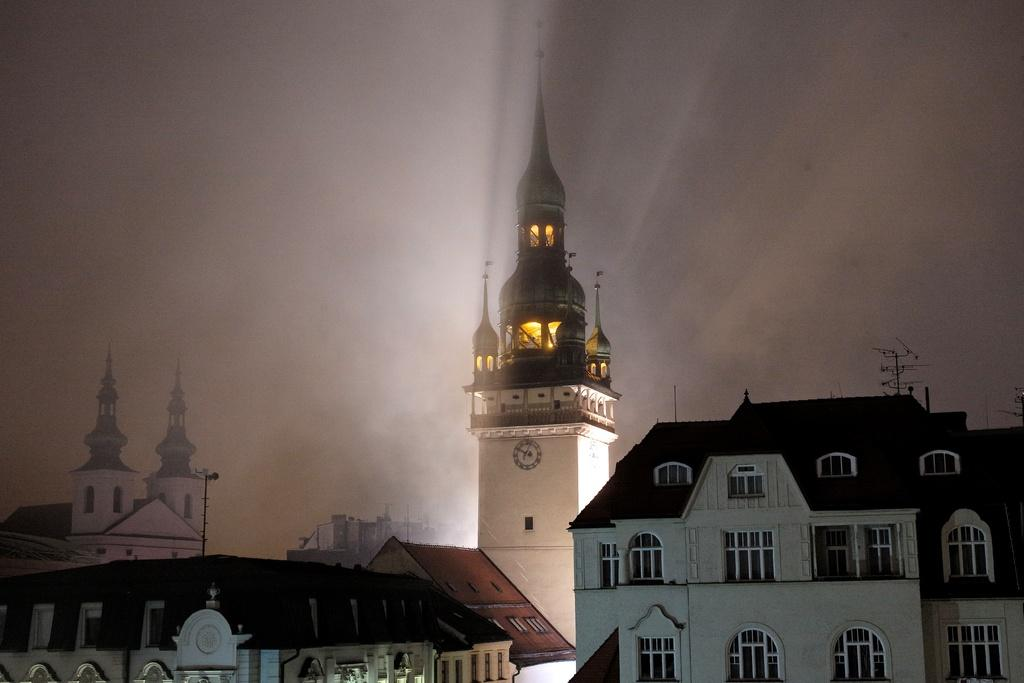What type of structures are present in the image? There are buildings in the image. Can you describe any specific features of these buildings? Yes, there is a clock attached to one of the buildings. What can be seen in the sky in the image? The sky is visible in the image, with a white and gray color. What type of fire can be seen burning near the roots of the buildings in the image? There is no fire or roots present in the image; it features buildings with a clock and a sky with a white and gray color. 